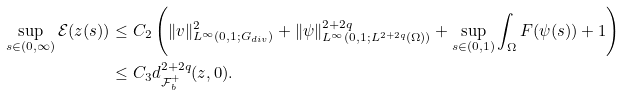<formula> <loc_0><loc_0><loc_500><loc_500>\sup _ { s \in ( 0 , \infty ) } \mathcal { E } ( z ( s ) ) & \leq C _ { 2 } \left ( \| v \| _ { L ^ { \infty } ( 0 , 1 ; G _ { d i v } ) } ^ { 2 } + \| \psi \| _ { L ^ { \infty } ( 0 , 1 ; L ^ { 2 + 2 q } ( \Omega ) ) } ^ { 2 + 2 q } + \sup _ { s \in ( 0 , 1 ) } \int _ { \Omega } F ( \psi ( s ) ) + 1 \right ) \\ & \leq C _ { 3 } d _ { \mathcal { F } _ { b } ^ { + } } ^ { 2 + 2 q } ( z , 0 ) .</formula> 